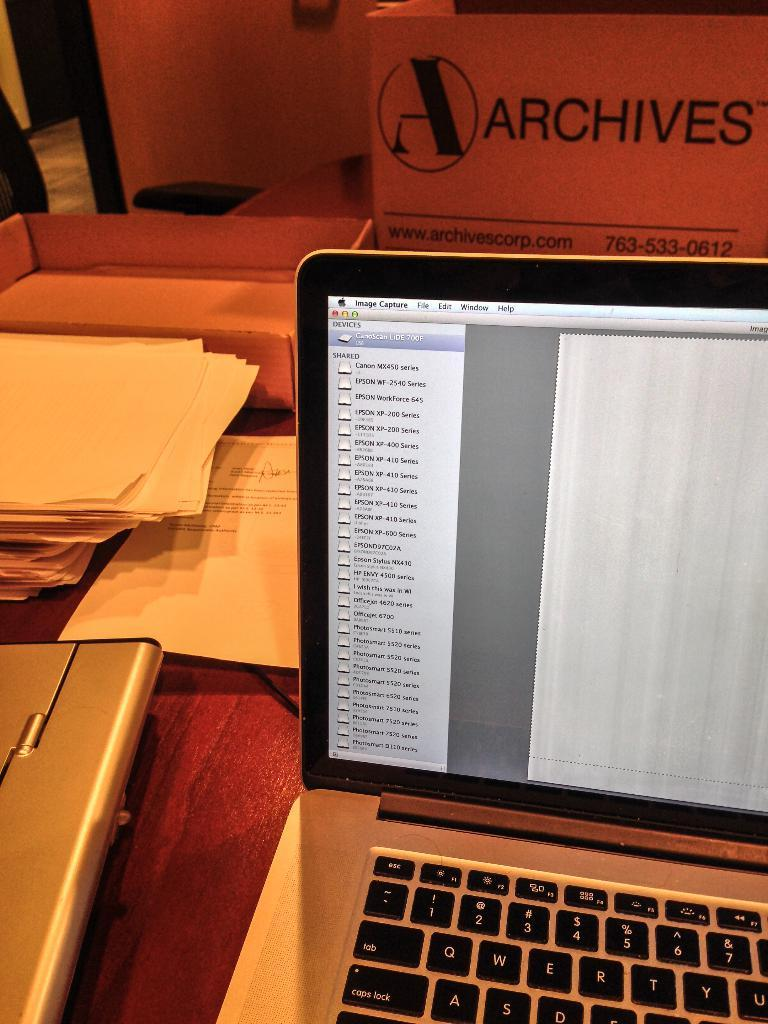<image>
Write a terse but informative summary of the picture. A laptop is open on a desk with papers and an Archives Box. 